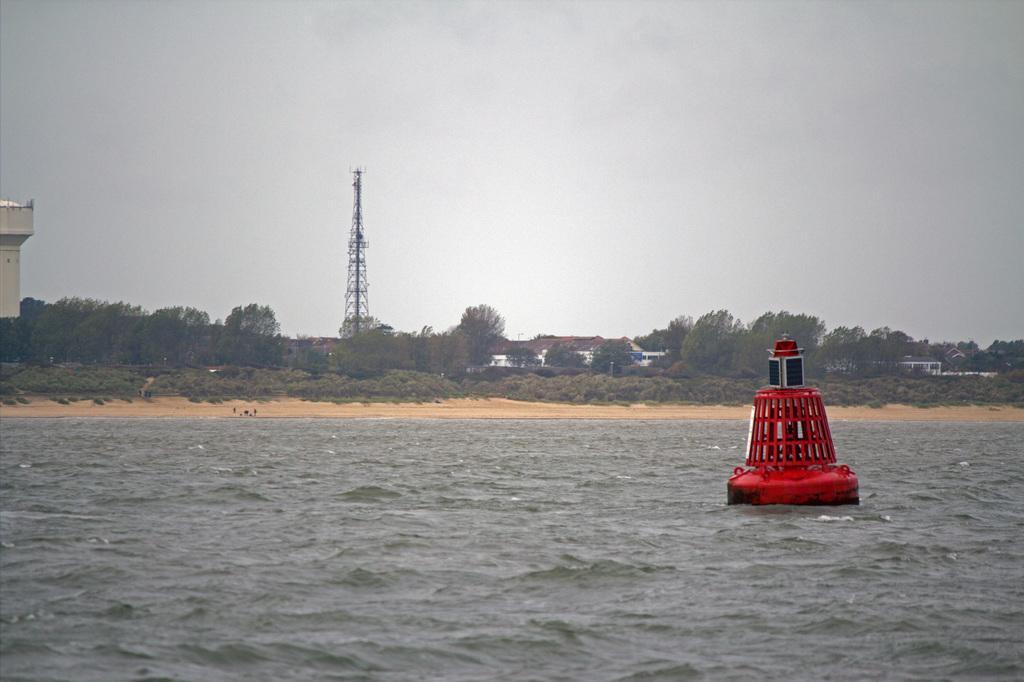Can you describe this image briefly? In this image I can see few houses, trees, tower, water tank and the red and black color object on the water surface. The sky is in blue and white color. 